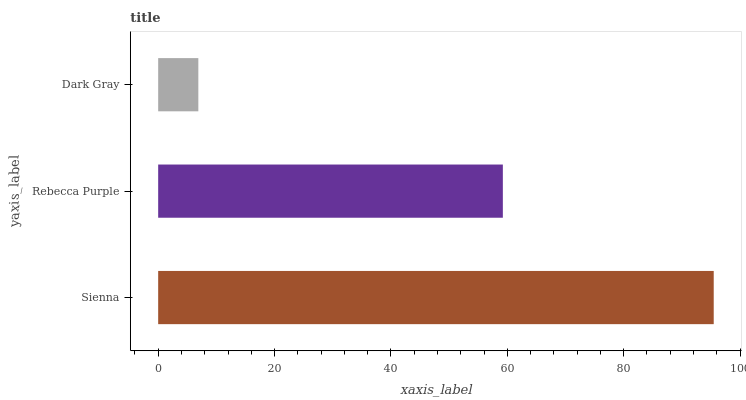Is Dark Gray the minimum?
Answer yes or no. Yes. Is Sienna the maximum?
Answer yes or no. Yes. Is Rebecca Purple the minimum?
Answer yes or no. No. Is Rebecca Purple the maximum?
Answer yes or no. No. Is Sienna greater than Rebecca Purple?
Answer yes or no. Yes. Is Rebecca Purple less than Sienna?
Answer yes or no. Yes. Is Rebecca Purple greater than Sienna?
Answer yes or no. No. Is Sienna less than Rebecca Purple?
Answer yes or no. No. Is Rebecca Purple the high median?
Answer yes or no. Yes. Is Rebecca Purple the low median?
Answer yes or no. Yes. Is Sienna the high median?
Answer yes or no. No. Is Dark Gray the low median?
Answer yes or no. No. 